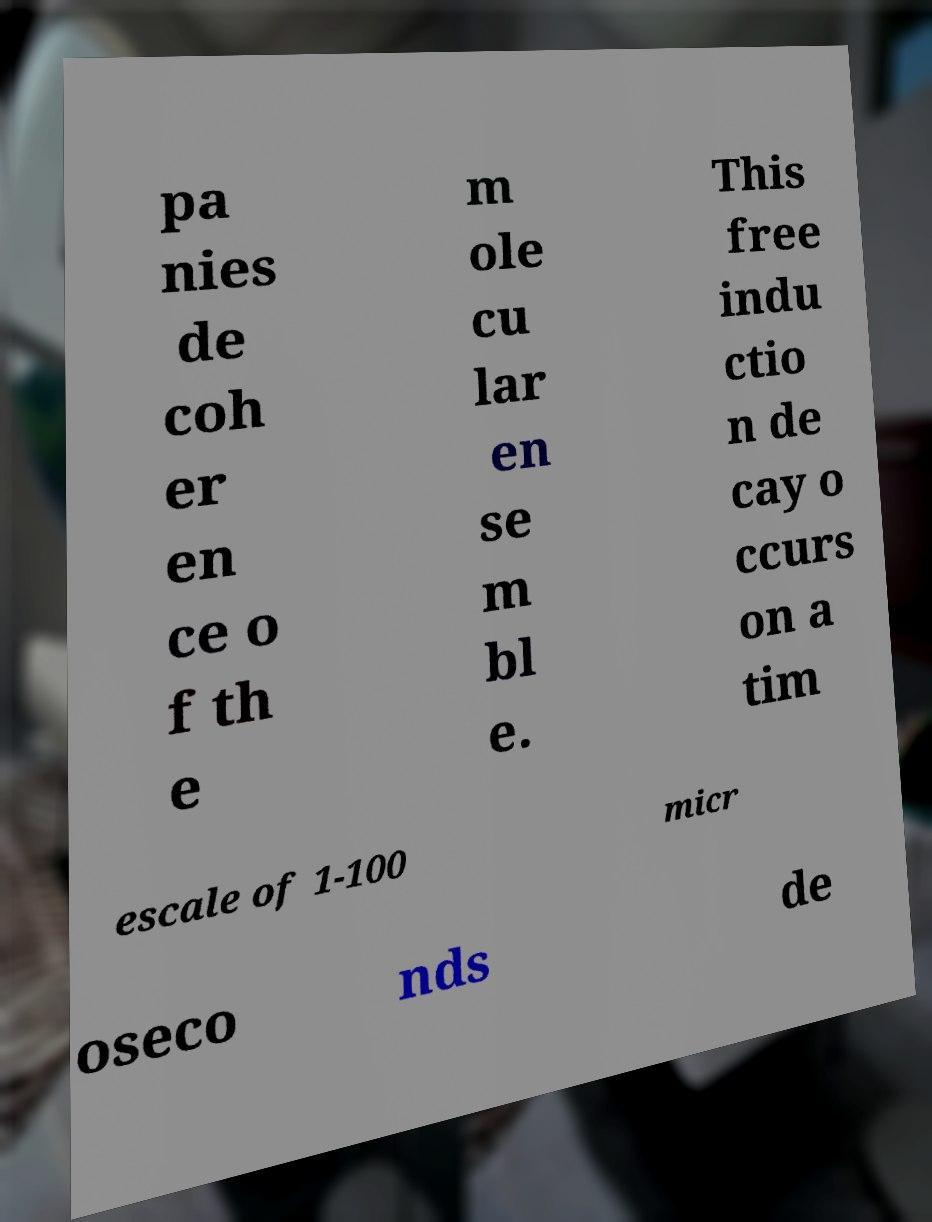Can you accurately transcribe the text from the provided image for me? pa nies de coh er en ce o f th e m ole cu lar en se m bl e. This free indu ctio n de cay o ccurs on a tim escale of 1-100 micr oseco nds de 